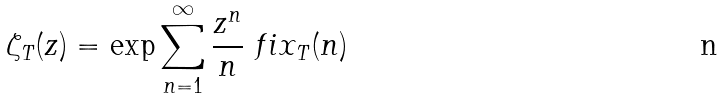Convert formula to latex. <formula><loc_0><loc_0><loc_500><loc_500>\zeta _ { T } ( z ) = \exp \sum _ { n = 1 } ^ { \infty } \frac { z ^ { n } } { n } \ f i x _ { T } ( n )</formula> 